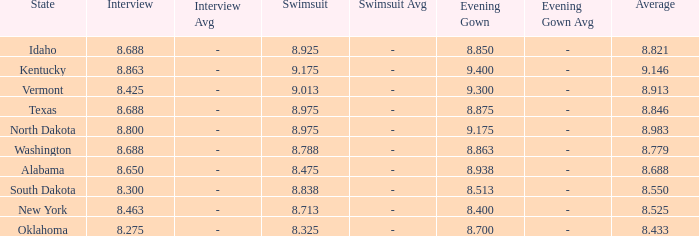What is the highest average of the contestant from Texas with an evening gown larger than 8.875? None. 